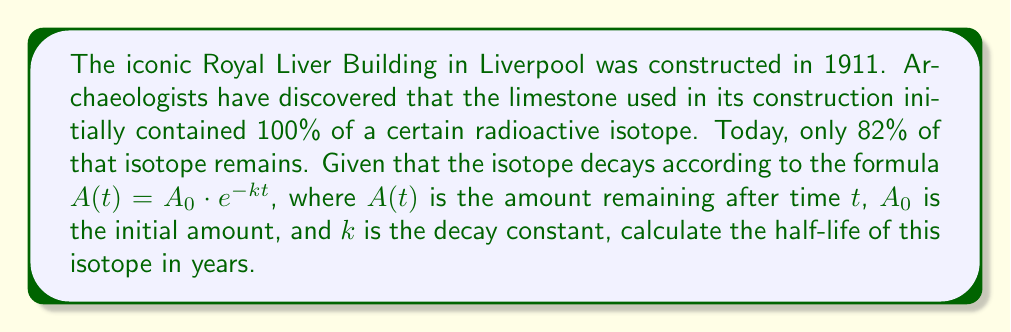Provide a solution to this math problem. Let's approach this step-by-step:

1) We know that $A(t) = A_0 \cdot e^{-kt}$, where:
   $A(t) = 82$ (82% remaining)
   $A_0 = 100$ (initial 100%)
   $t = 2023 - 1911 = 112$ years

2) Substituting these values:
   $82 = 100 \cdot e^{-k(112)}$

3) Dividing both sides by 100:
   $0.82 = e^{-112k}$

4) Taking the natural log of both sides:
   $\ln(0.82) = -112k$

5) Solving for $k$:
   $k = -\frac{\ln(0.82)}{112} \approx 0.001767$

6) The half-life $t_{1/2}$ is the time it takes for half of the substance to decay. It's related to $k$ by:
   $t_{1/2} = \frac{\ln(2)}{k}$

7) Substituting our value for $k$:
   $t_{1/2} = \frac{\ln(2)}{0.001767} \approx 392.3$ years

Therefore, the half-life of the isotope is approximately 392 years.
Answer: 392 years 